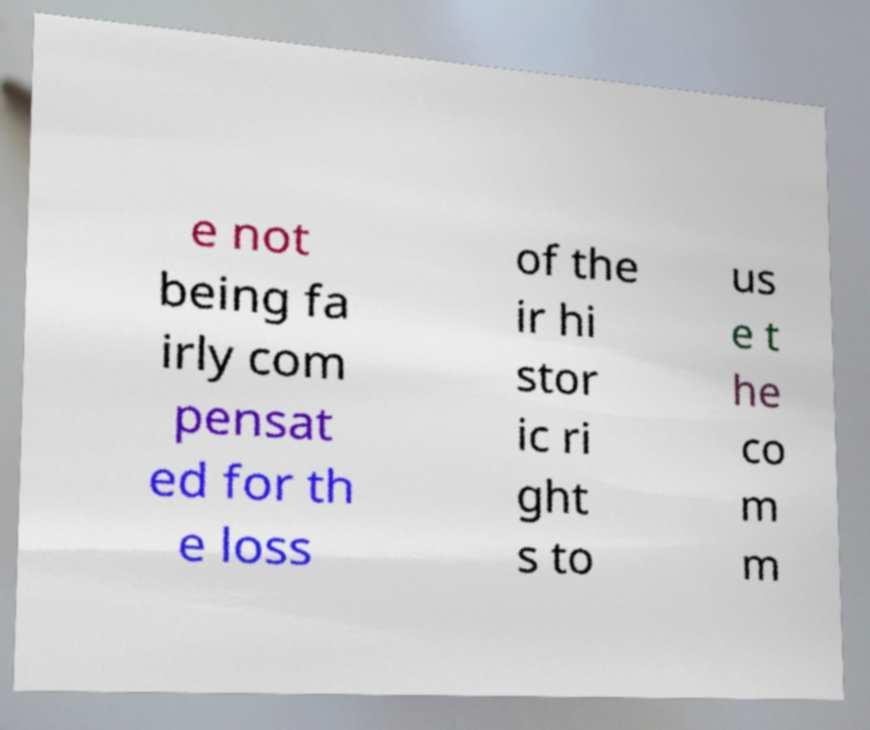Please identify and transcribe the text found in this image. e not being fa irly com pensat ed for th e loss of the ir hi stor ic ri ght s to us e t he co m m 